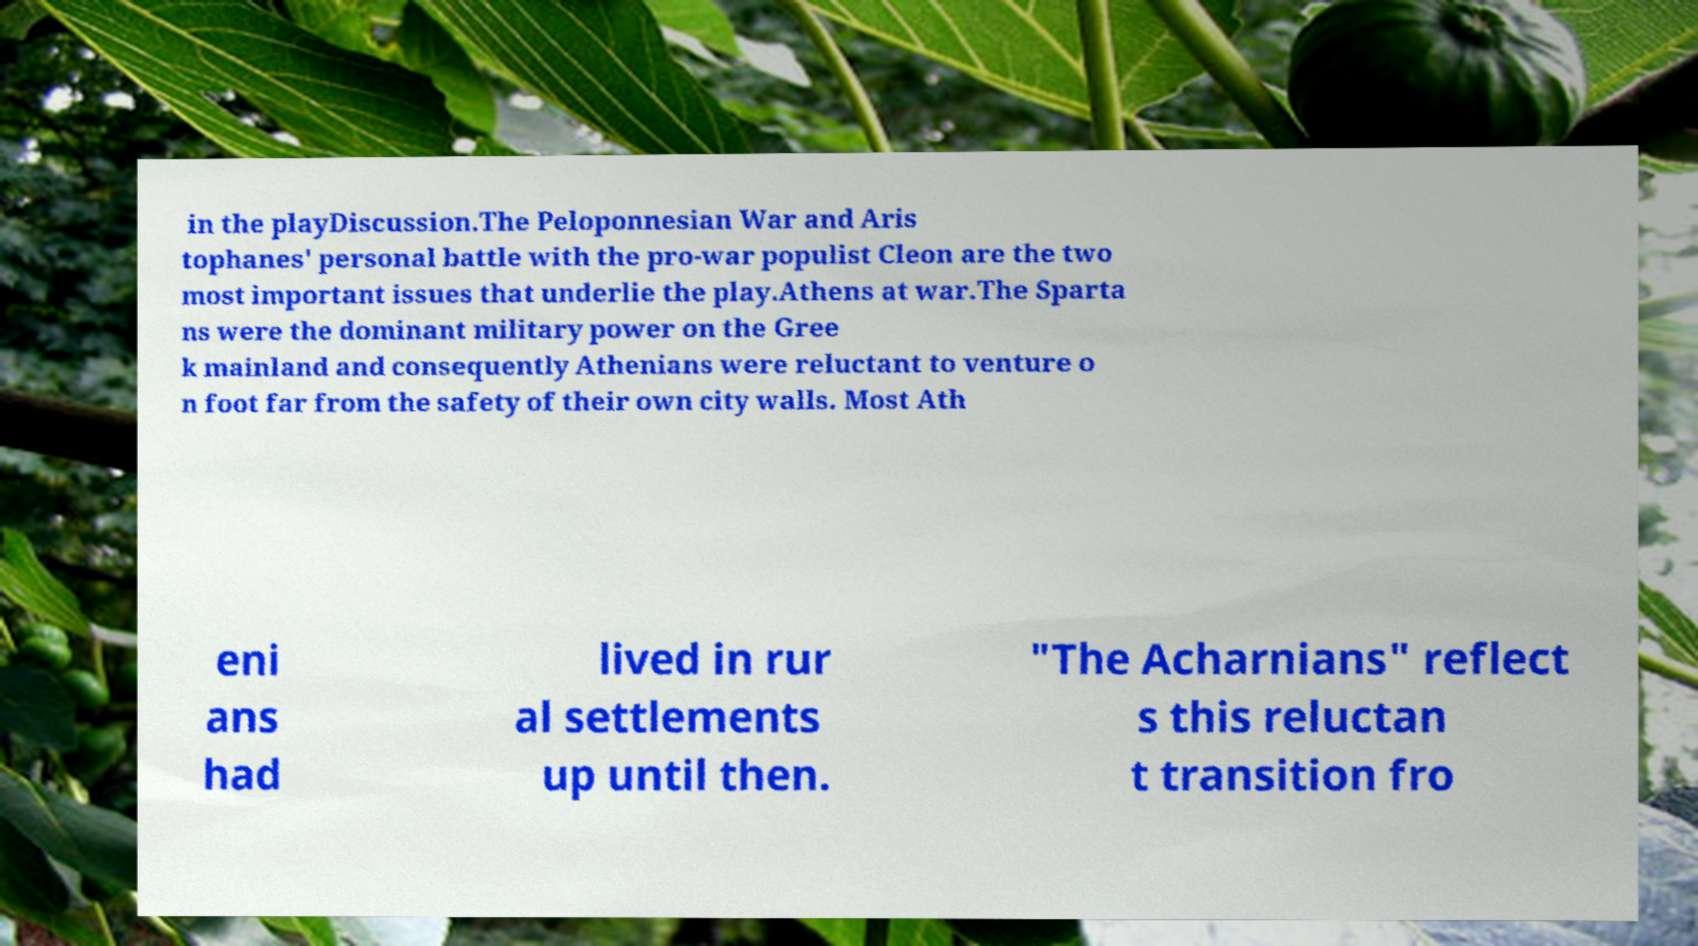Could you assist in decoding the text presented in this image and type it out clearly? in the playDiscussion.The Peloponnesian War and Aris tophanes' personal battle with the pro-war populist Cleon are the two most important issues that underlie the play.Athens at war.The Sparta ns were the dominant military power on the Gree k mainland and consequently Athenians were reluctant to venture o n foot far from the safety of their own city walls. Most Ath eni ans had lived in rur al settlements up until then. "The Acharnians" reflect s this reluctan t transition fro 